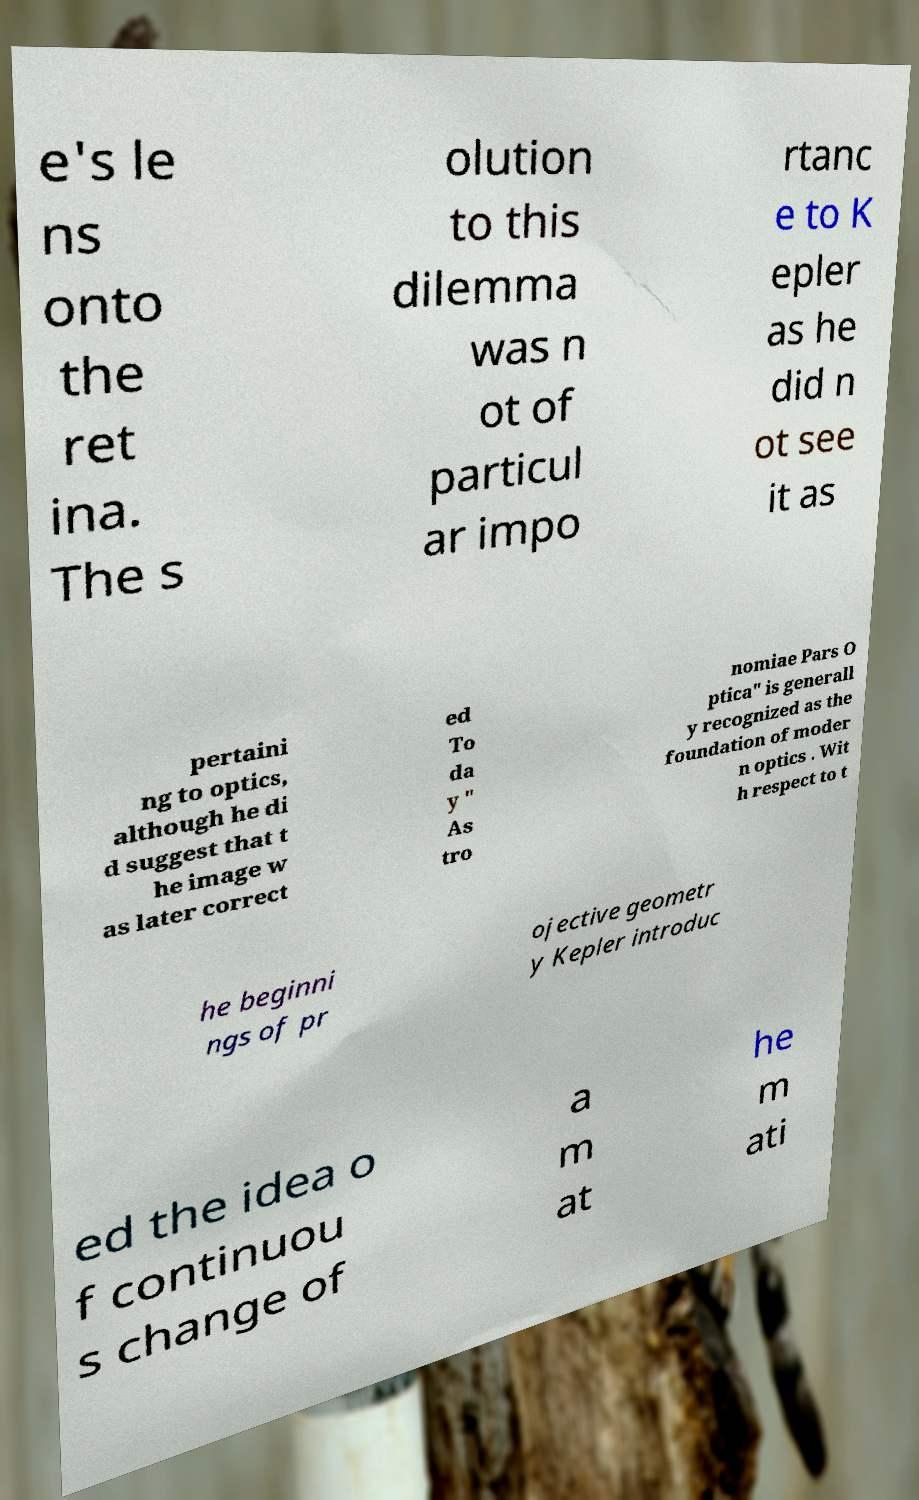I need the written content from this picture converted into text. Can you do that? e's le ns onto the ret ina. The s olution to this dilemma was n ot of particul ar impo rtanc e to K epler as he did n ot see it as pertaini ng to optics, although he di d suggest that t he image w as later correct ed To da y " As tro nomiae Pars O ptica" is generall y recognized as the foundation of moder n optics . Wit h respect to t he beginni ngs of pr ojective geometr y Kepler introduc ed the idea o f continuou s change of a m at he m ati 